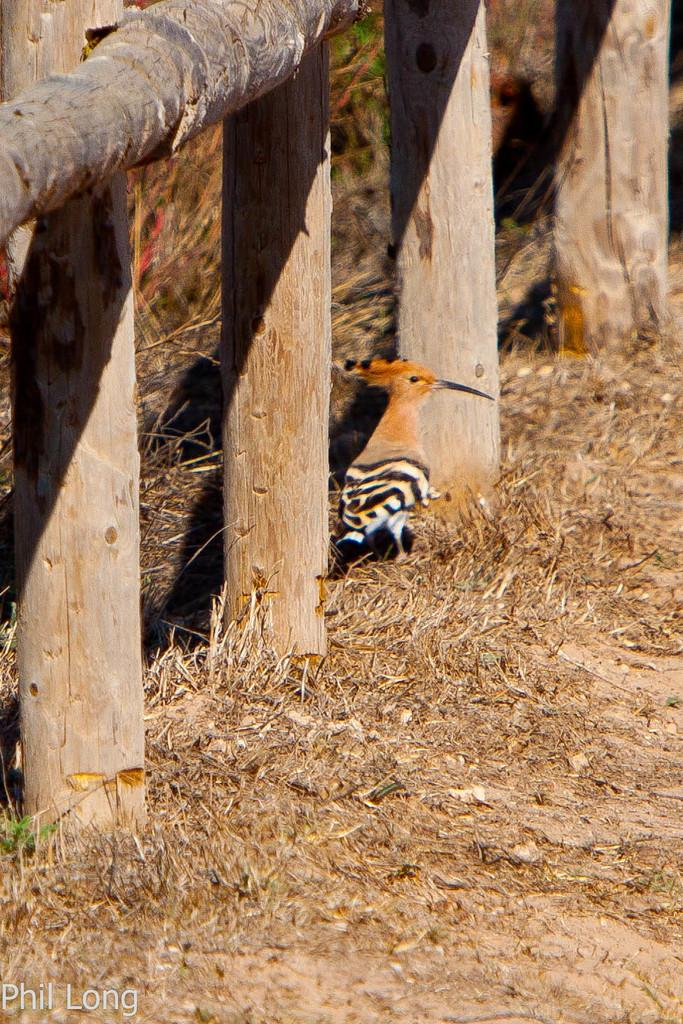What is located on the left side of the image? There is a boundary on the left side of the image. What can be seen in the center of the image? There is a bird in the center of the image. What type of science experiment is being conducted with the tiger in the image? There is no tiger or science experiment present in the image. Is the stove visible in the image? There is no stove present in the image. 